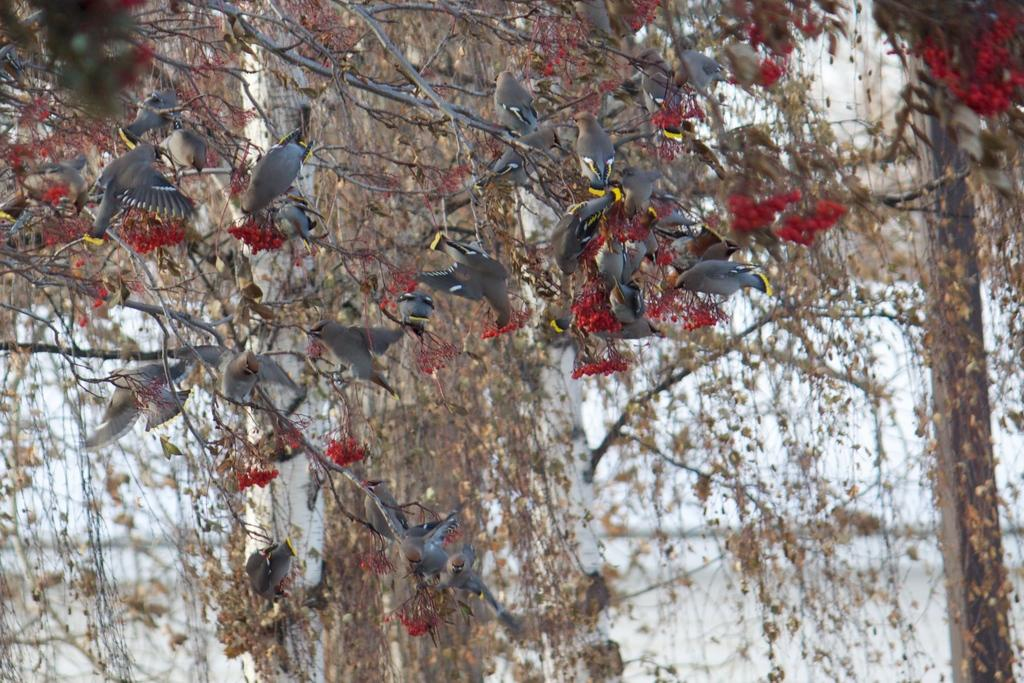What type of vegetation is present in the image? There are trees in the image. Are there any animals visible in the image? Yes, there are birds on one of the trees. What can be seen on the right side of the image? There is a pole on the right side of the image. What is visible in the background of the image? The sky is visible in the image. What type of powder is being used by the birds in the image? There is no powder present in the image, and the birds are not using any powder. 